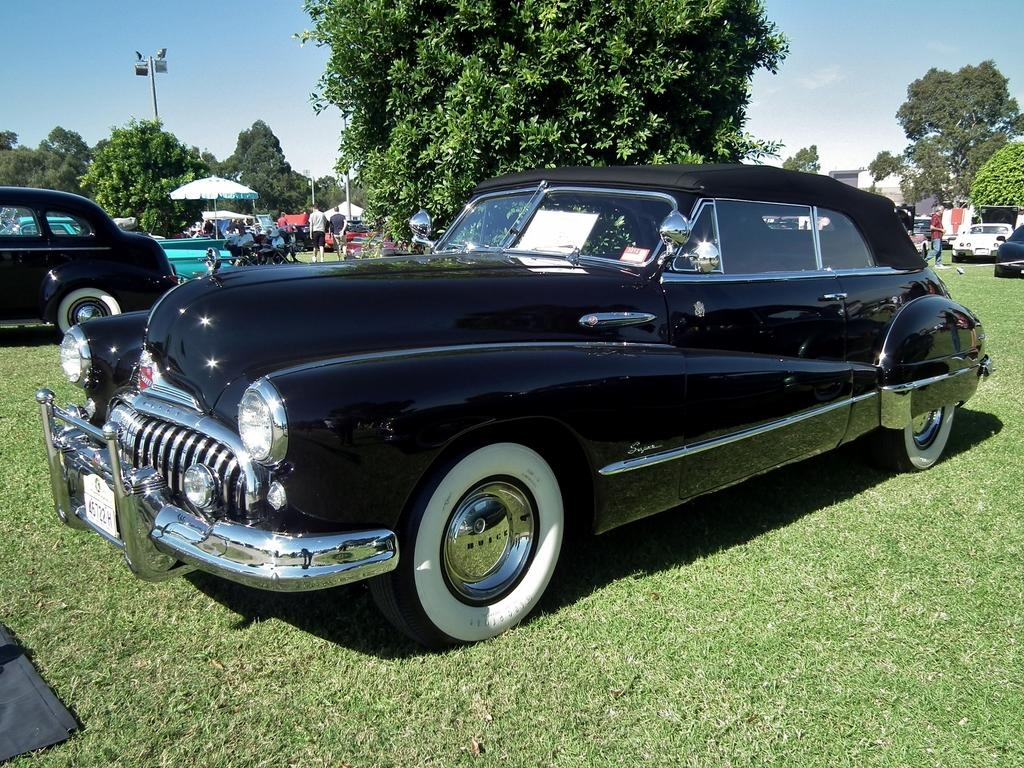What type of vehicles are on the ground in the image? There are cars on the ground in the image. What type of vegetation can be seen in the image? There is grass, trees, and poles in the image. What object is used for protection from the sun or rain in the image? There is an umbrella in the image. Can you describe the people in the image? There are people in the image, but their specific actions or characteristics are not mentioned in the provided facts. What is visible in the background of the image? The sky is visible in the background of the image. What instrument is being played by the slave in the image? There is no mention of a slave or an instrument being played in the image. The image only contains cars, grass, an umbrella, poles, trees, and people. 